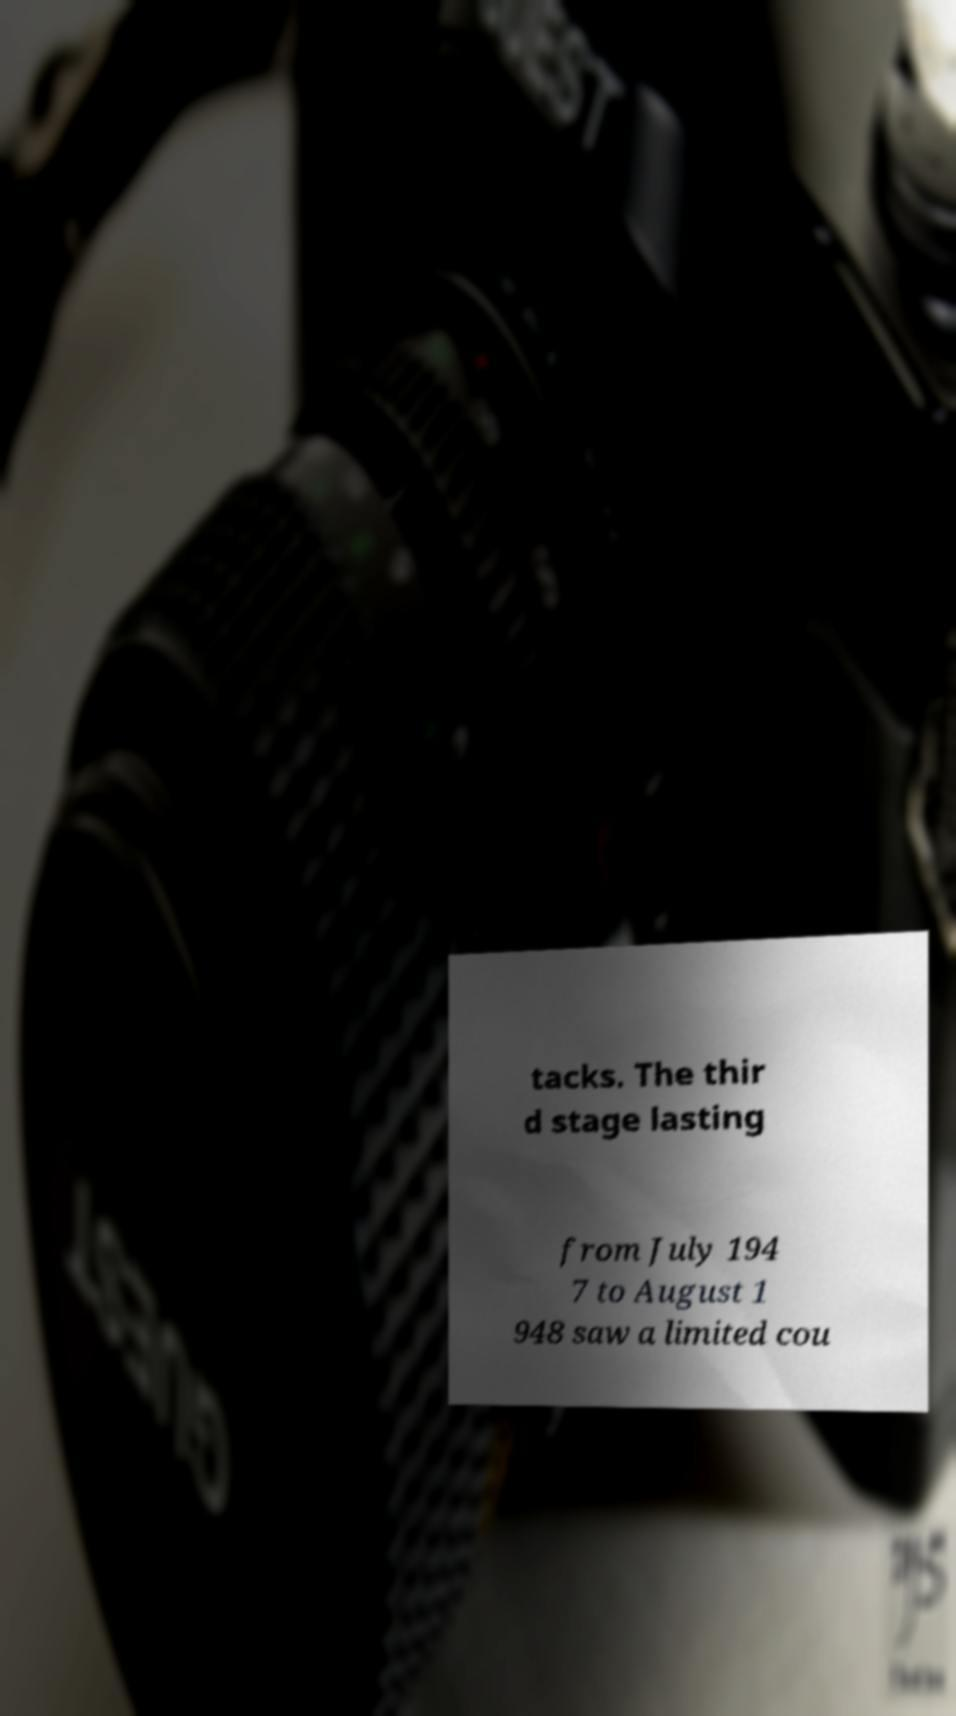Could you extract and type out the text from this image? tacks. The thir d stage lasting from July 194 7 to August 1 948 saw a limited cou 